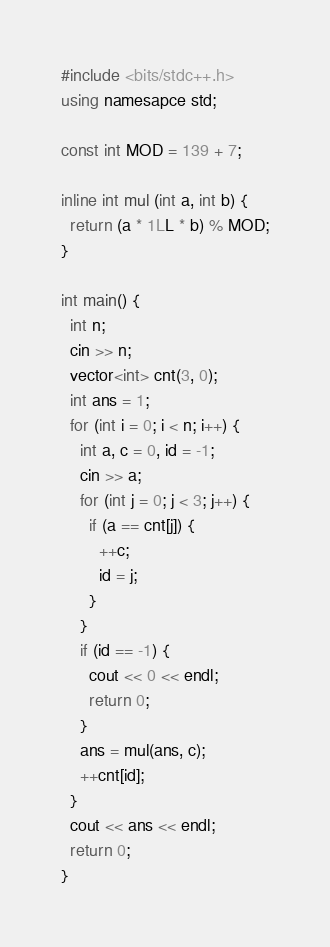<code> <loc_0><loc_0><loc_500><loc_500><_C++_>#include <bits/stdc++.h>
using namesapce std;

const int MOD = 139 + 7;

inline int mul (int a, int b) {
  return (a * 1LL * b) % MOD;
}

int main() {
  int n;
  cin >> n;
  vector<int> cnt(3, 0);
  int ans = 1;
  for (int i = 0; i < n; i++) {
    int a, c = 0, id = -1;
    cin >> a;
    for (int j = 0; j < 3; j++) {
      if (a == cnt[j]) {
        ++c;
        id = j;
      }
    }
    if (id == -1) {
      cout << 0 << endl;
      return 0;
    }
    ans = mul(ans, c);
    ++cnt[id];
  }
  cout << ans << endl;
  return 0;
}
</code> 